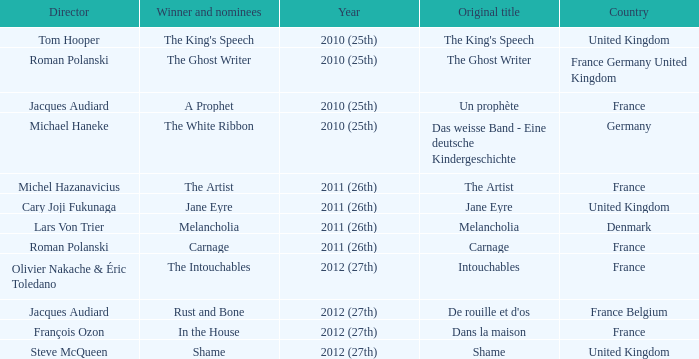Who was the director of the king's speech? Tom Hooper. 